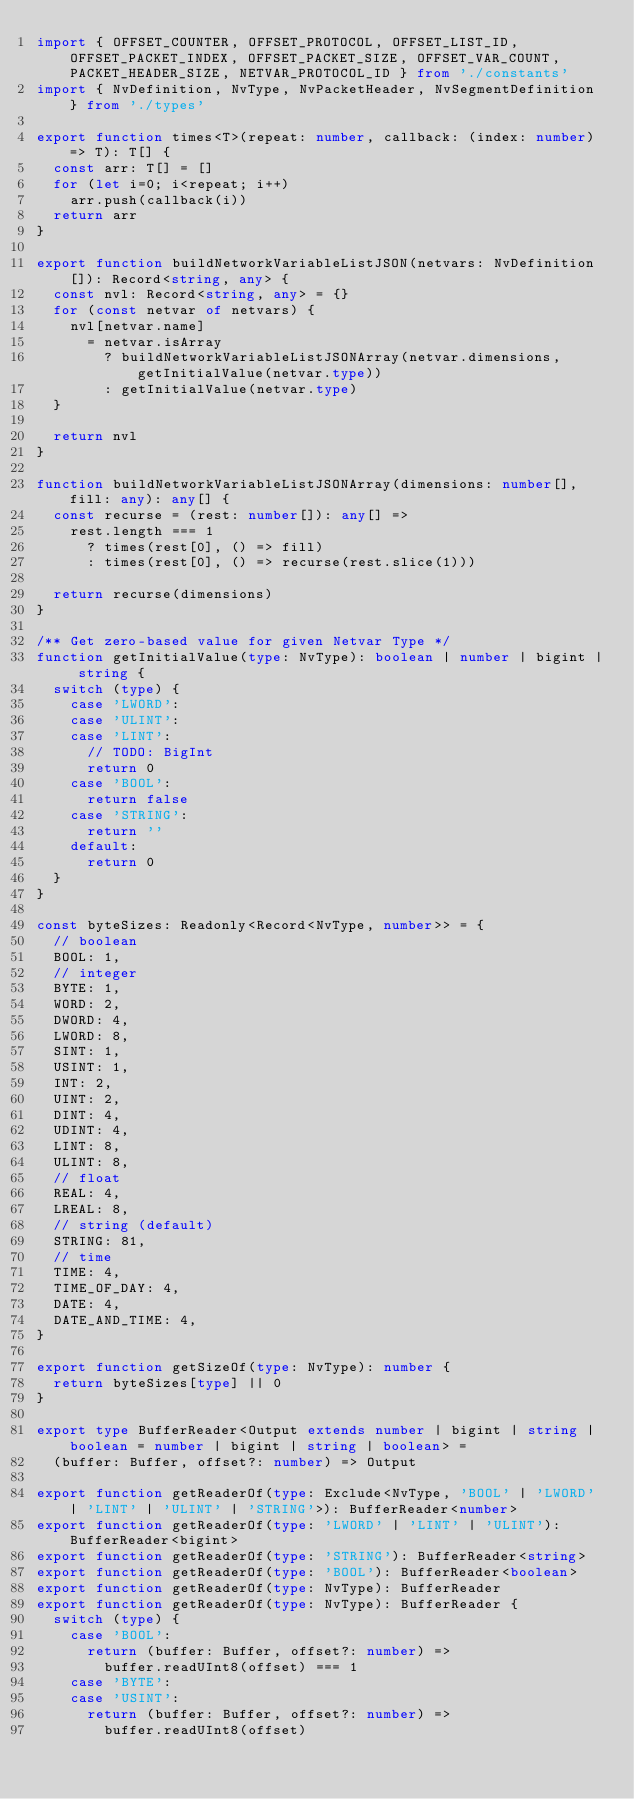<code> <loc_0><loc_0><loc_500><loc_500><_TypeScript_>import { OFFSET_COUNTER, OFFSET_PROTOCOL, OFFSET_LIST_ID, OFFSET_PACKET_INDEX, OFFSET_PACKET_SIZE, OFFSET_VAR_COUNT, PACKET_HEADER_SIZE, NETVAR_PROTOCOL_ID } from './constants'
import { NvDefinition, NvType, NvPacketHeader, NvSegmentDefinition } from './types'

export function times<T>(repeat: number, callback: (index: number) => T): T[] {
  const arr: T[] = []
  for (let i=0; i<repeat; i++)
    arr.push(callback(i))
  return arr
}

export function buildNetworkVariableListJSON(netvars: NvDefinition[]): Record<string, any> {
  const nvl: Record<string, any> = {}
  for (const netvar of netvars) {
    nvl[netvar.name]
      = netvar.isArray
        ? buildNetworkVariableListJSONArray(netvar.dimensions, getInitialValue(netvar.type))
        : getInitialValue(netvar.type)
  }

  return nvl
}

function buildNetworkVariableListJSONArray(dimensions: number[], fill: any): any[] {
  const recurse = (rest: number[]): any[] => 
    rest.length === 1
      ? times(rest[0], () => fill)
      : times(rest[0], () => recurse(rest.slice(1)))
  
  return recurse(dimensions)
}

/** Get zero-based value for given Netvar Type */
function getInitialValue(type: NvType): boolean | number | bigint | string {
  switch (type) {
    case 'LWORD':
    case 'ULINT':
    case 'LINT':
      // TODO: BigInt
      return 0
    case 'BOOL':
      return false
    case 'STRING':
      return ''
    default:
      return 0
  }
}

const byteSizes: Readonly<Record<NvType, number>> = {
  // boolean
  BOOL: 1,
  // integer
  BYTE: 1,
  WORD: 2,
  DWORD: 4,
  LWORD: 8,
  SINT: 1,
  USINT: 1,
  INT: 2,
  UINT: 2,
  DINT: 4,
  UDINT: 4,
  LINT: 8,
  ULINT: 8,
  // float
  REAL: 4,
  LREAL: 8,
  // string (default)
  STRING: 81,
  // time
  TIME: 4,
  TIME_OF_DAY: 4,
  DATE: 4,
  DATE_AND_TIME: 4,
}

export function getSizeOf(type: NvType): number {
  return byteSizes[type] || 0
}

export type BufferReader<Output extends number | bigint | string | boolean = number | bigint | string | boolean> = 
  (buffer: Buffer, offset?: number) => Output

export function getReaderOf(type: Exclude<NvType, 'BOOL' | 'LWORD' | 'LINT' | 'ULINT' | 'STRING'>): BufferReader<number> 
export function getReaderOf(type: 'LWORD' | 'LINT' | 'ULINT'): BufferReader<bigint> 
export function getReaderOf(type: 'STRING'): BufferReader<string> 
export function getReaderOf(type: 'BOOL'): BufferReader<boolean>
export function getReaderOf(type: NvType): BufferReader
export function getReaderOf(type: NvType): BufferReader {
  switch (type) {
    case 'BOOL':
      return (buffer: Buffer, offset?: number) =>
        buffer.readUInt8(offset) === 1
    case 'BYTE':
    case 'USINT':
      return (buffer: Buffer, offset?: number) =>
        buffer.readUInt8(offset)</code> 